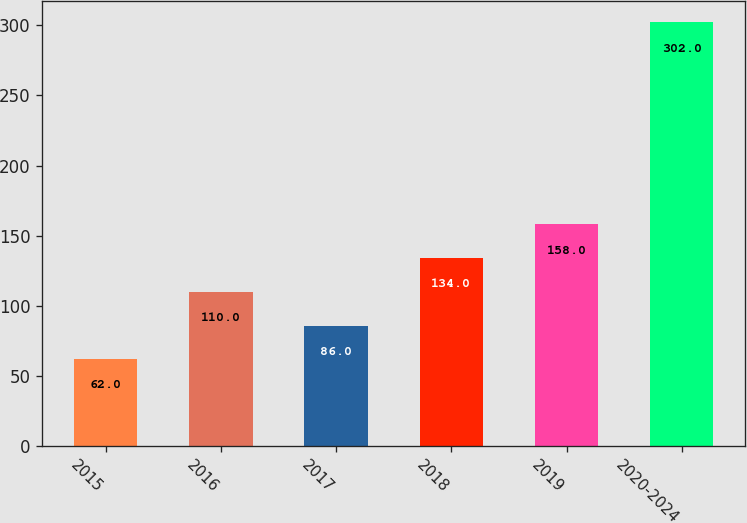Convert chart. <chart><loc_0><loc_0><loc_500><loc_500><bar_chart><fcel>2015<fcel>2016<fcel>2017<fcel>2018<fcel>2019<fcel>2020-2024<nl><fcel>62<fcel>110<fcel>86<fcel>134<fcel>158<fcel>302<nl></chart> 